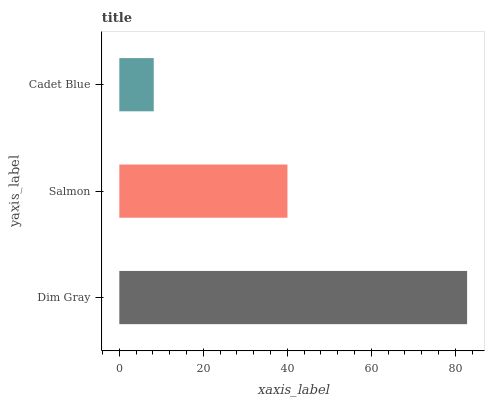Is Cadet Blue the minimum?
Answer yes or no. Yes. Is Dim Gray the maximum?
Answer yes or no. Yes. Is Salmon the minimum?
Answer yes or no. No. Is Salmon the maximum?
Answer yes or no. No. Is Dim Gray greater than Salmon?
Answer yes or no. Yes. Is Salmon less than Dim Gray?
Answer yes or no. Yes. Is Salmon greater than Dim Gray?
Answer yes or no. No. Is Dim Gray less than Salmon?
Answer yes or no. No. Is Salmon the high median?
Answer yes or no. Yes. Is Salmon the low median?
Answer yes or no. Yes. Is Cadet Blue the high median?
Answer yes or no. No. Is Dim Gray the low median?
Answer yes or no. No. 